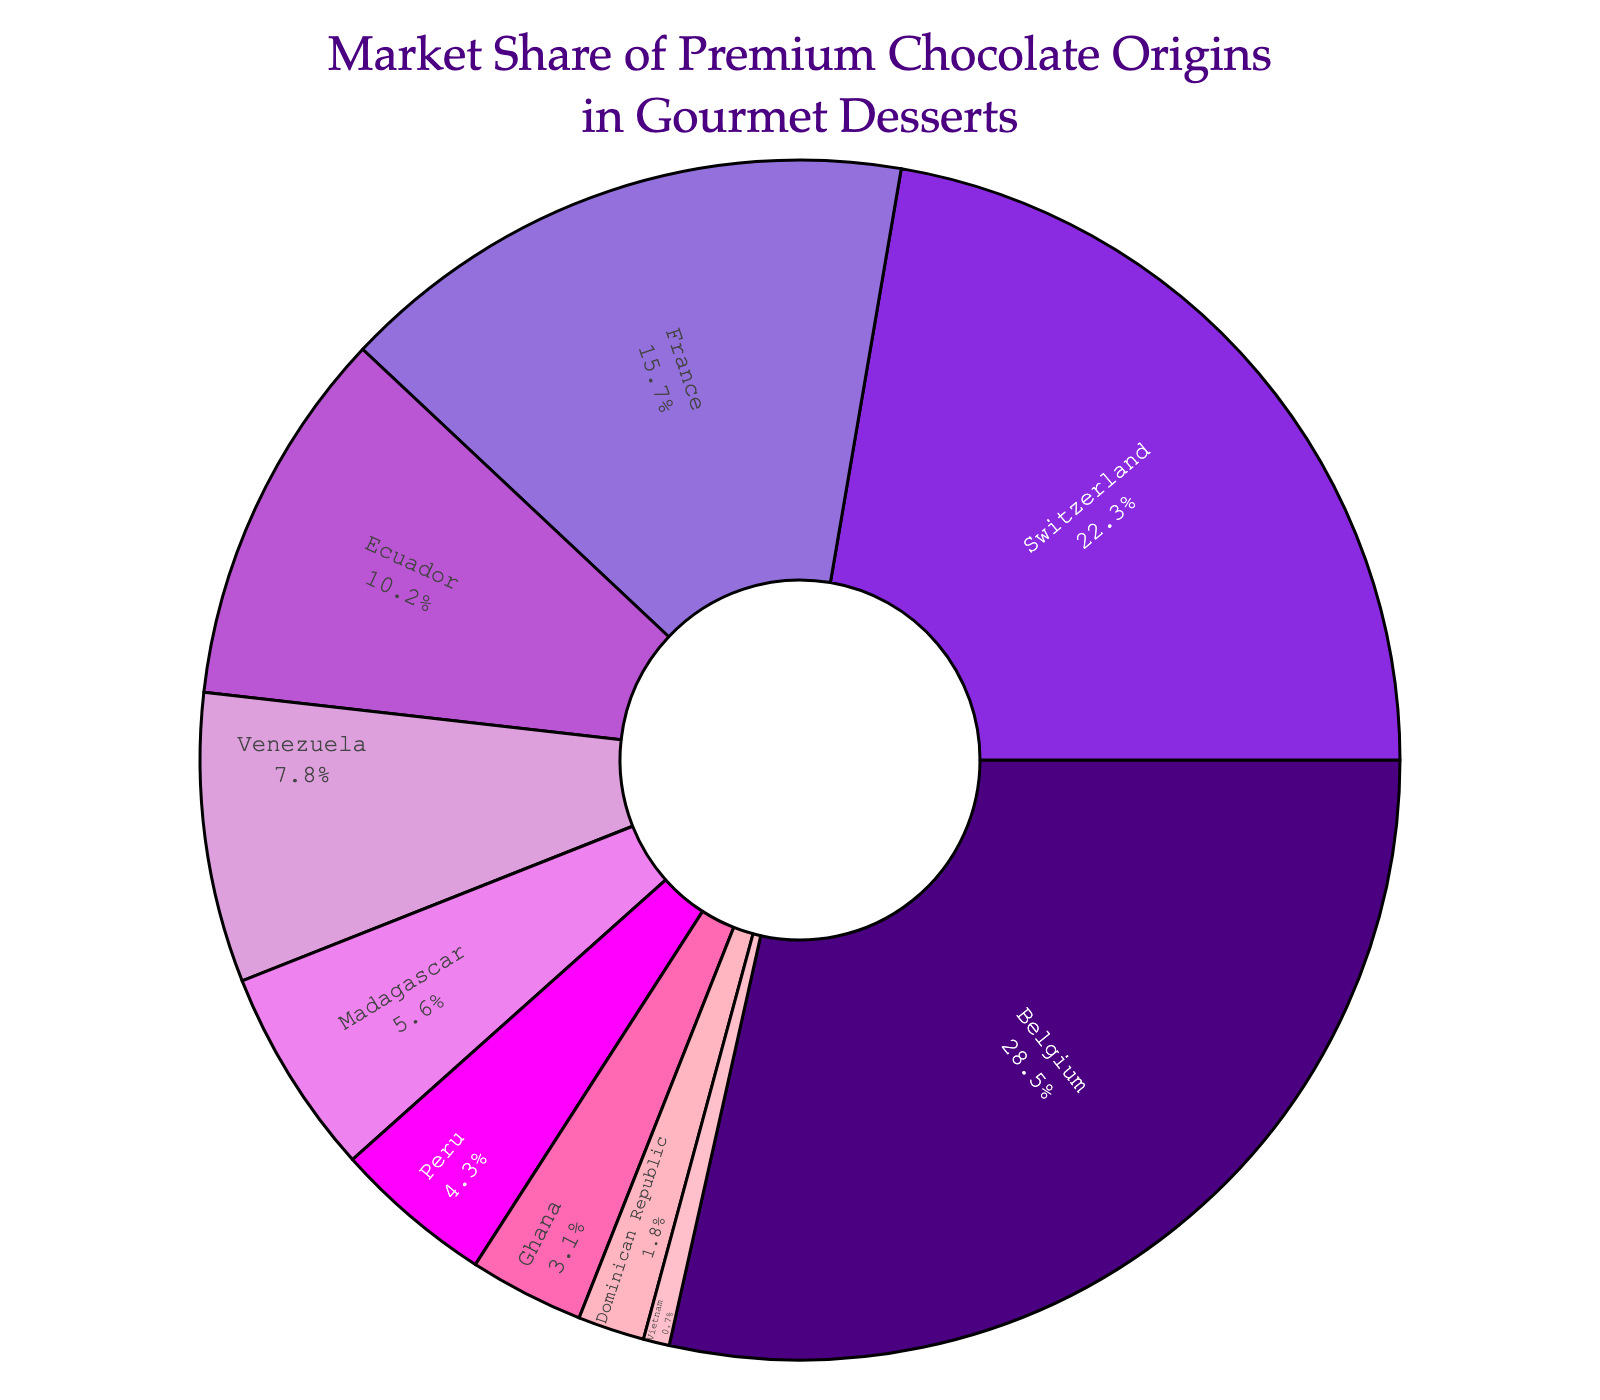Which origin has the highest market share in gourmet desserts? Look at the largest slice in the pie chart, which is labeled "Belgium" with the highest percentage of 28.5%.
Answer: Belgium What is the total market share percentage of chocolate origins from Ecuador and Venezuela? The market share for Ecuador is 10.2%, and for Venezuela, it is 7.8%. Add these two percentages: 10.2% + 7.8% = 18%.
Answer: 18% How much larger is the market share of Switzerland compared to France? The market share of Switzerland is 22.3%, and France is 15.7%. Subtract the market share of France from Switzerland: 22.3% - 15.7% = 6.6%.
Answer: 6.6% Which slice in the pie chart has the smallest market share and what is its value? The smallest slice in the pie chart corresponds to "Vietnam" and is marked with 0.7%.
Answer: Vietnam, 0.7% What is the combined market share of European origins (Belgium, Switzerland, France)? Sum the market shares of Belgium, Switzerland, and France: 28.5% + 22.3% + 15.7% = 66.5%.
Answer: 66.5% What is the difference in market share between the origin with the highest and the origin with the lowest market share? The highest market share is Belgium with 28.5%, and the lowest is Vietnam with 0.7%. Subtract the lowest from the highest: 28.5% - 0.7% = 27.8%.
Answer: 27.8% How many origins have a market share below 5%? Count the number of slices in the pie chart with percentages below 5%: Peru (4.3%), Ghana (3.1%), Dominican Republic (1.8%), Vietnam (0.7%). There are 4 such origins.
Answer: 4 What percentage of the market share is held by African origins (Madagascar, Ghana)? Sum the market shares of Madagascar and Ghana: 5.6% + 3.1% = 8.7%.
Answer: 8.7% If the market share of Switzerland increased by 5%, what would the new market share be? Increase Switzerland's market share of 22.3% by 5%: 22.3% + 5% = 27.3%.
Answer: 27.3% What is the average market share of the origins that hold less than 10%? Add the market shares of Ecuador, Venezuela, Madagascar, Peru, Ghana, Dominican Republic, and Vietnam (10.2 + 7.8 + 5.6 + 4.3 + 3.1 + 1.8 + 0.7) and divide by the number of these origins (7): (10.2 + 7.8 + 5.6 + 4.3 + 3.1 + 1.8 + 0.7) / 7 = 33.5 / 7 ≈ 4.79%.
Answer: ≈ 4.79% 